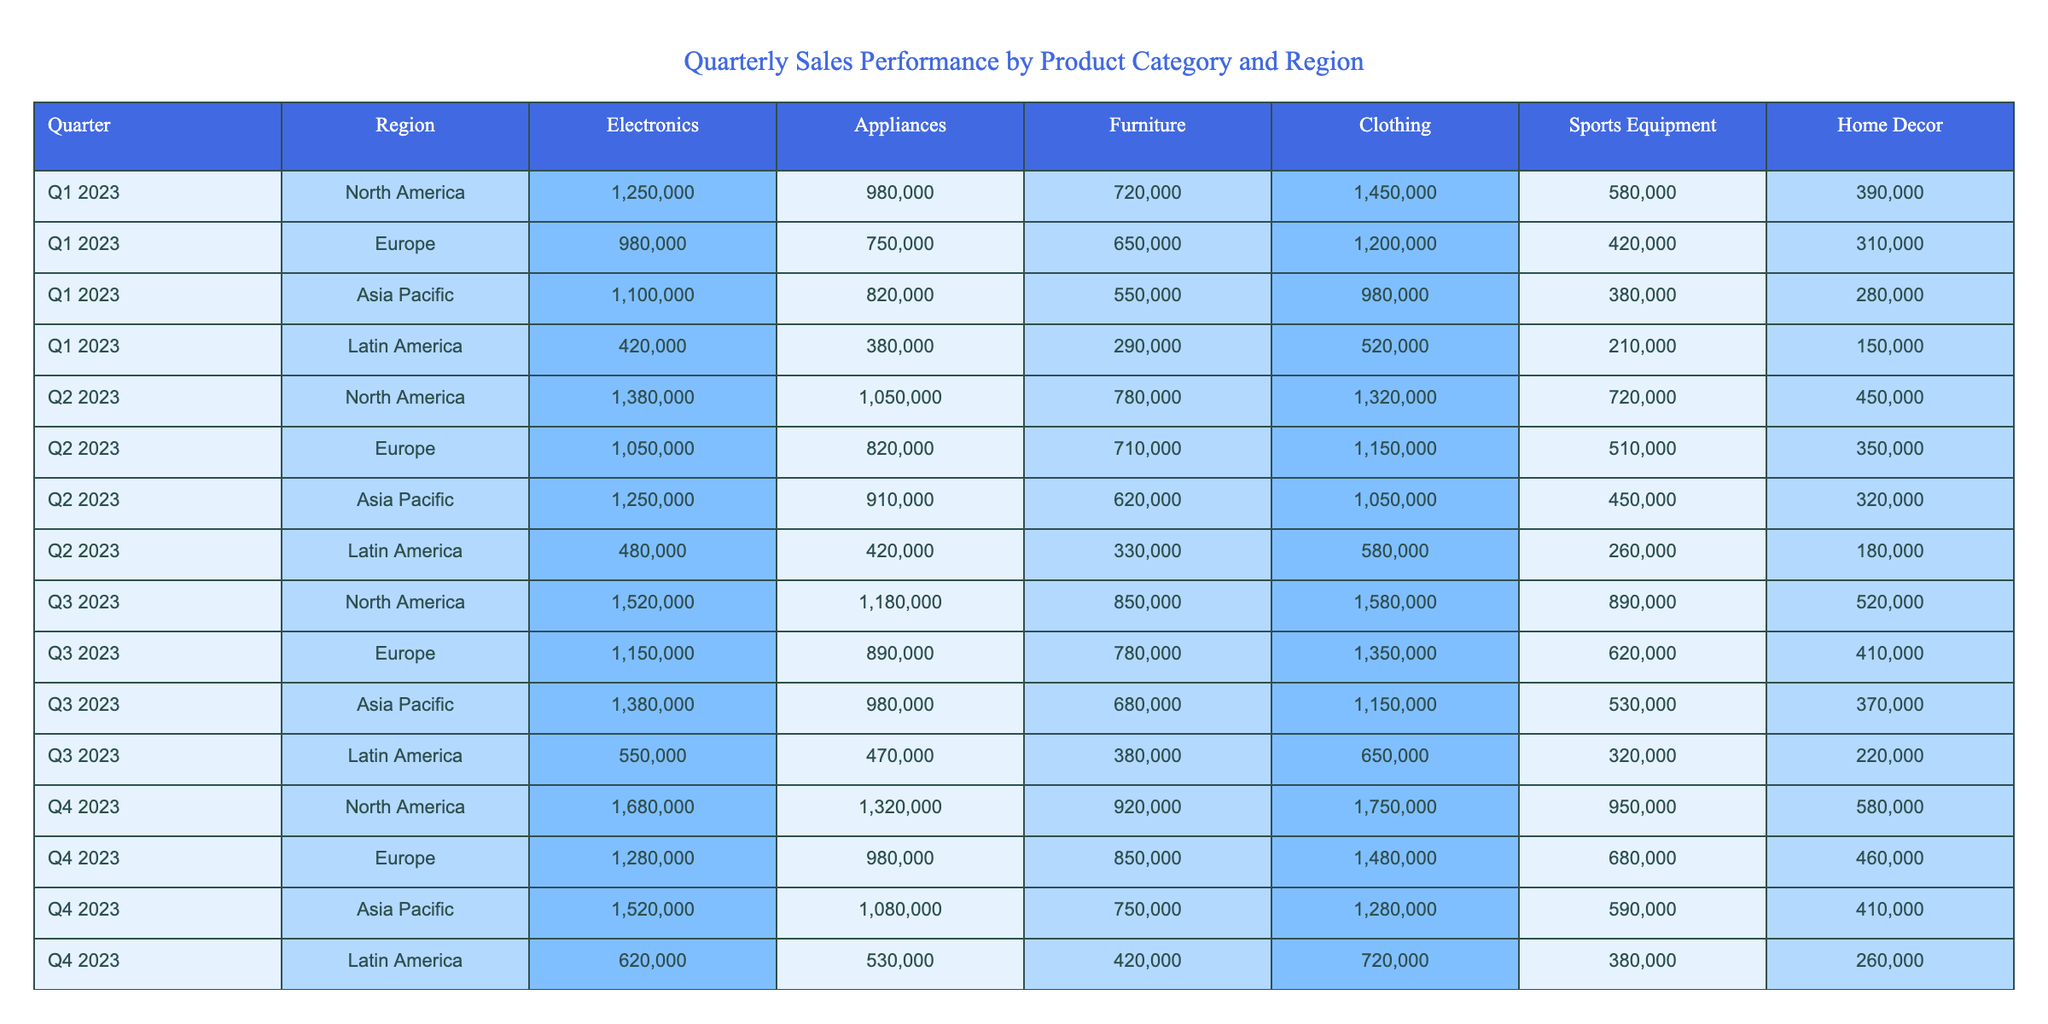What were the total sales for Electronics in North America in Q2 2023? The sales figure for Electronics in North America for Q2 2023 is 1,380,000, which can be found under the respective row and column in the table.
Answer: 1,380,000 What is the highest sales figure for Furniture across all regions in Q4 2023? In Q4 2023, the Furniture sales figures are 920,000 for North America, 850,000 for Europe, 750,000 for Asia Pacific, and 420,000 for Latin America. The highest value is 920,000 from North America.
Answer: 920,000 Which region had the least sales for Clothing in Q1 2023? The sales figures for Clothing in Q1 2023 are 1,450,000 for North America, 1,200,000 for Europe, 980,000 for Asia Pacific, and 520,000 for Latin America. The least value is 520,000 from Latin America.
Answer: Latin America What was the average sales figure for Home Decor across all regions in Q3 2023? The Home Decor sales figures for Q3 2023 are 520,000 for North America, 410,000 for Europe, 370,000 for Asia Pacific, and 220,000 for Latin America. To find the average, we sum these values: (520,000 + 410,000 + 370,000 + 220,000) = 1,520,000, and then divide by 4, resulting in 1,520,000 / 4 = 380,000.
Answer: 380,000 Did Latin America have more sales in Appliances during Q4 2023 compared to Q3 2023? In Q4 2023, Latin America had sales of 530,000 in Appliances, while in Q3 2023, the sales were 470,000. Since 530,000 is greater than 470,000, the answer is yes.
Answer: Yes What is the percentage increase in sales for Sports Equipment in North America from Q2 2023 to Q3 2023? In Q2 2023, Sports Equipment sales in North America were 720,000, and in Q3 2023, they increased to 890,000. To find the percentage increase: (890,000 - 720,000) / 720,000 * 100 = 23.61%.
Answer: 23.61% Which product category had the highest total sales in Asia Pacific for the entire year of 2023? Summing all sales figures for each category in Asia Pacific for the four quarters gives: Electronics (1,100,000 + 1,250,000 + 1,380,000 + 1,520,000), Appliances (820,000 + 910,000 + 980,000 + 1,080,000), Furniture (550,000 + 620,000 + 680,000 + 750,000), Clothing (980,000 + 1,050,000 + 1,150,000 + 1,280,000), Sports Equipment (380,000 + 450,000 + 530,000 + 590,000), and Home Decor (280,000 + 320,000 + 370,000 + 410,000). The highest total is for Clothing at 4,460,000.
Answer: Clothing What is the difference in total sales of Electronics between North America and Europe in Q1 2023? For Q1 2023, Electronics sales in North America were 1,250,000 and in Europe, it was 980,000. The difference is 1,250,000 - 980,000 = 270,000.
Answer: 270,000 Which region had a decrease in sales for Home Decor from Q1 2023 to Q4 2023? Examining the sales figures for Home Decor shows 390,000 in Q1 2023 (North America) compared to 580,000 in Q4 2023 (North America), and similarly for other regions there are increases in each comparison. No region showed a decrease.
Answer: No region Which product category consistently had the lowest sales in Latin America across all four quarters? By looking at the sales figures for Latin America, we see that the category with the lowest sales in each quarter (Q1: 150,000, Q2: 180,000, Q3: 220,000, Q4: 260,000) is Home Decor, which has the lowest sales overall.
Answer: Home Decor 